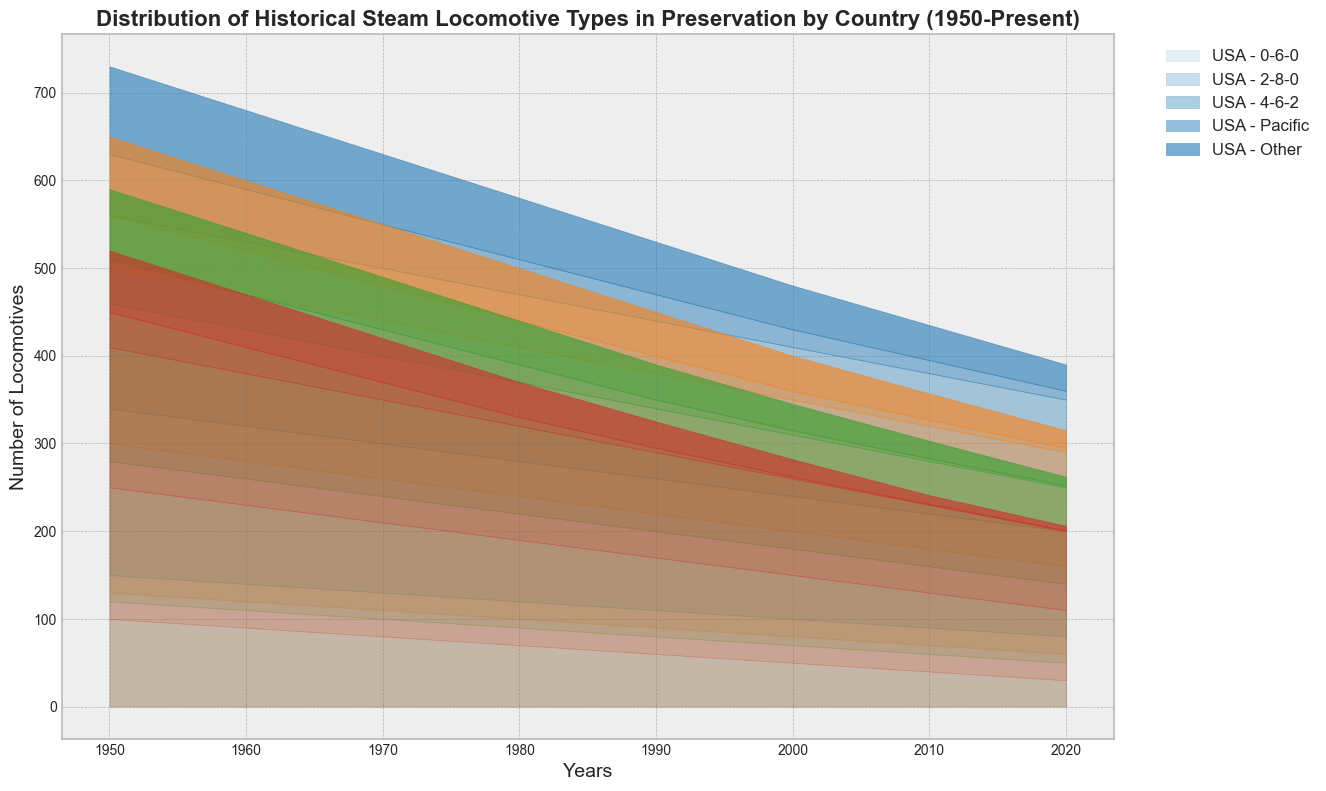What's the country with the highest number of preserved 0-6-0 locomotives in 1980? According to the chart, the USA has the highest number of preserved 0-6-0 locomotives in 1980. We see that "0-6-0" locomotives are represented at the bottom part of the chart and the USA bars extend the furthest in 1980.
Answer: USA How has the number of 4-6-2 locomotives preserved in the UK changed from 1950 to 2020? Observing the chart, the bars representing the UK for 4-6-2 locomotives, situated towards the middle of the stack, start at a high level in 1950 and gradually decrease over time, reaching much lower in 2020.
Answer: Decreased Which country has the smallest number of preserved locomotives in total in 2020? By looking at the total height of the stacked area for each country in 2020, France has the smallest overall height, indicating it has the fewest preserved locomotives.
Answer: France Compare the number of 'Other' type locomotives preserved in France between 1960 and 2020. The 'Other' type is the uppermost part of the stacked areas. From 1960 to 2020, the height markedly drops, indicating a reduction in the number of preserved 'Other' locomotives in France.
Answer: Fewer in 2020 What was the trend in the number of preserved Pacific type locomotives in Germany from 1950 to 1990? Noticing the chart, the Pacific type locomotives (second from the top) in Germany show a consistent decline from 1950 through to 1990. The stacked areas for Pacific types become lower over these years.
Answer: Decreasing trend What fraction of the total preserved locomotives in the USA in 2020 are 2-8-0 types? First, observe the 2020 total height for USA. The 2-8-0 type represents the second layer from the bottom. We compare the height contributed by 2-8-0 type to the total height.
Answer: About 1/3 Which country experienced the most significant reduction in the preservation of locomotives from 1950 to 2020? By observing the overall height difference of the stacked areas from 1950 to 2020, France shows the most dramatic reduction. Their total stacked area significantly shrinks over the years.
Answer: France What is the visual trend of the number of preserved 2-8-0 locomotives in the USA from 1950 to 2020? The 2-8-0 locomotives in the USA (second layer in the stack) show a consistent decreasing trend in height from 1950 to 2020, indicating a gradual reduction in their number.
Answer: Decreasing trend Which country had more preserved 4-6-2 locomotives in 2000, UK or Germany? By comparing the 4-6-2 layers (third from bottom) in 2000 for the UK and Germany, the UK stack is slightly higher, meaning more preserved 4-6-2 locomotives in the UK than in Germany.
Answer: UK How does the total number of preserved locomotives in France in 1990 compare to the UK in the same year? By comparing the total stack heights for France and the UK in 1990, the UK has a substantially taller stack, indicating more preserved locomotives than France.
Answer: UK has more 